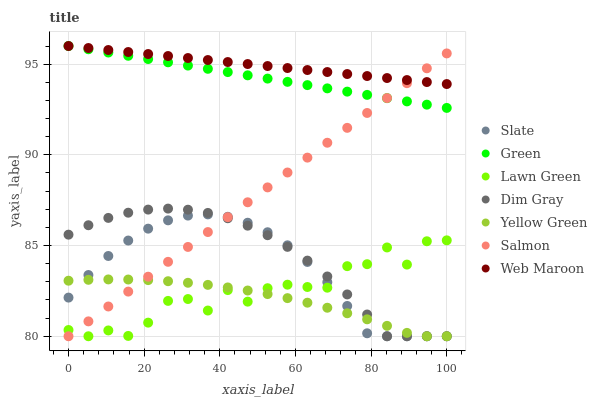Does Yellow Green have the minimum area under the curve?
Answer yes or no. Yes. Does Web Maroon have the maximum area under the curve?
Answer yes or no. Yes. Does Dim Gray have the minimum area under the curve?
Answer yes or no. No. Does Dim Gray have the maximum area under the curve?
Answer yes or no. No. Is Salmon the smoothest?
Answer yes or no. Yes. Is Lawn Green the roughest?
Answer yes or no. Yes. Is Dim Gray the smoothest?
Answer yes or no. No. Is Dim Gray the roughest?
Answer yes or no. No. Does Lawn Green have the lowest value?
Answer yes or no. Yes. Does Web Maroon have the lowest value?
Answer yes or no. No. Does Green have the highest value?
Answer yes or no. Yes. Does Dim Gray have the highest value?
Answer yes or no. No. Is Dim Gray less than Green?
Answer yes or no. Yes. Is Web Maroon greater than Yellow Green?
Answer yes or no. Yes. Does Dim Gray intersect Lawn Green?
Answer yes or no. Yes. Is Dim Gray less than Lawn Green?
Answer yes or no. No. Is Dim Gray greater than Lawn Green?
Answer yes or no. No. Does Dim Gray intersect Green?
Answer yes or no. No. 